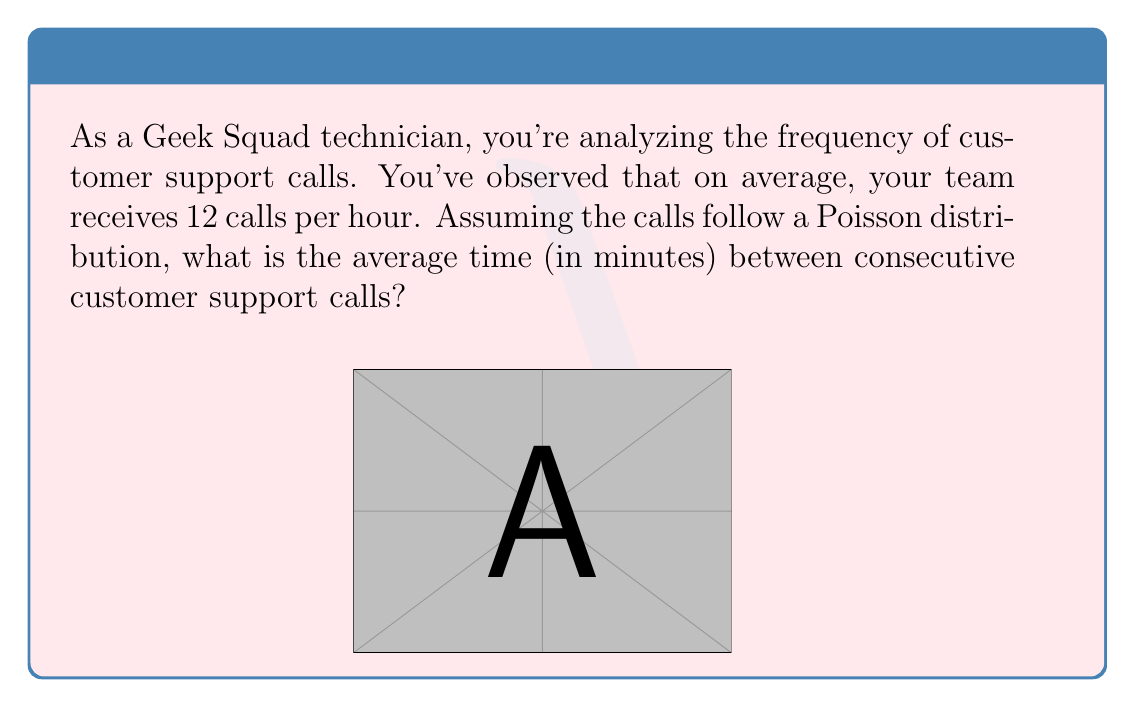Help me with this question. Let's approach this step-by-step:

1) First, we need to understand what we're given:
   - The average number of calls per hour is 12
   - The calls follow a Poisson distribution

2) In a Poisson distribution, the average number of events in an interval is denoted by λ (lambda).
   In this case, λ = 12 calls per hour

3) To find the average time between calls, we need to find the inverse of the rate:
   
   Average time between events = $\frac{1}{\text{rate}}$

4) We have the rate in calls per hour, but we want the result in minutes. So, let's convert:
   
   Rate = 12 calls/hour = $\frac{12}{60}$ calls/minute = 0.2 calls/minute

5) Now we can calculate the average time between calls:

   Average time = $\frac{1}{\text{rate}} = \frac{1}{0.2} = 5$ minutes

Therefore, on average, there are 5 minutes between consecutive customer support calls.
Answer: 5 minutes 